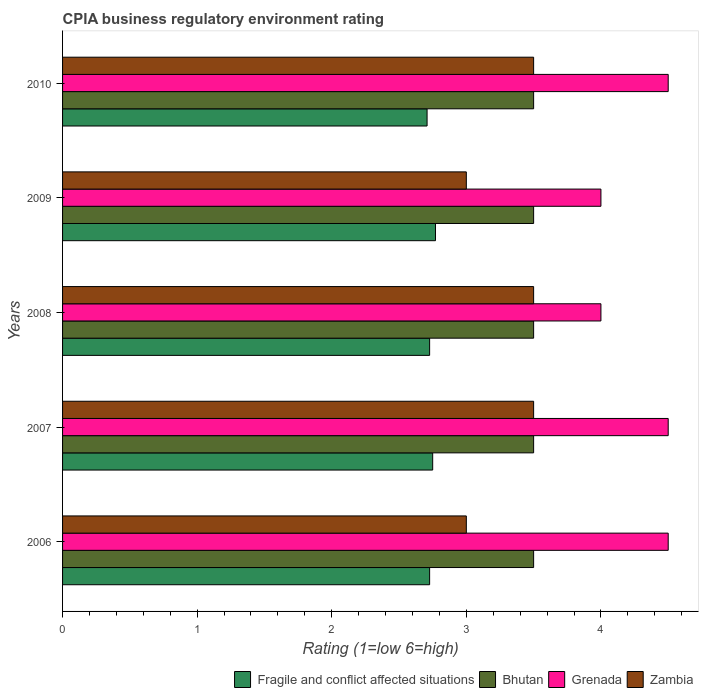How many different coloured bars are there?
Keep it short and to the point. 4. How many groups of bars are there?
Keep it short and to the point. 5. Are the number of bars per tick equal to the number of legend labels?
Keep it short and to the point. Yes. Across all years, what is the maximum CPIA rating in Fragile and conflict affected situations?
Provide a succinct answer. 2.77. Across all years, what is the minimum CPIA rating in Fragile and conflict affected situations?
Make the answer very short. 2.71. In which year was the CPIA rating in Zambia maximum?
Ensure brevity in your answer.  2007. What is the total CPIA rating in Fragile and conflict affected situations in the graph?
Your answer should be very brief. 13.68. What is the difference between the CPIA rating in Grenada in 2007 and that in 2008?
Provide a short and direct response. 0.5. What is the average CPIA rating in Fragile and conflict affected situations per year?
Ensure brevity in your answer.  2.74. In the year 2006, what is the difference between the CPIA rating in Bhutan and CPIA rating in Fragile and conflict affected situations?
Keep it short and to the point. 0.77. In how many years, is the CPIA rating in Grenada greater than 4.4 ?
Give a very brief answer. 3. What is the ratio of the CPIA rating in Fragile and conflict affected situations in 2008 to that in 2009?
Make the answer very short. 0.98. Is the CPIA rating in Bhutan in 2007 less than that in 2008?
Offer a very short reply. No. What is the difference between the highest and the lowest CPIA rating in Fragile and conflict affected situations?
Your answer should be very brief. 0.06. In how many years, is the CPIA rating in Zambia greater than the average CPIA rating in Zambia taken over all years?
Your answer should be very brief. 3. Is it the case that in every year, the sum of the CPIA rating in Zambia and CPIA rating in Fragile and conflict affected situations is greater than the sum of CPIA rating in Grenada and CPIA rating in Bhutan?
Your answer should be very brief. Yes. What does the 3rd bar from the top in 2006 represents?
Give a very brief answer. Bhutan. What does the 1st bar from the bottom in 2007 represents?
Your answer should be very brief. Fragile and conflict affected situations. Does the graph contain any zero values?
Give a very brief answer. No. What is the title of the graph?
Make the answer very short. CPIA business regulatory environment rating. What is the Rating (1=low 6=high) of Fragile and conflict affected situations in 2006?
Provide a short and direct response. 2.73. What is the Rating (1=low 6=high) in Bhutan in 2006?
Make the answer very short. 3.5. What is the Rating (1=low 6=high) of Grenada in 2006?
Your answer should be very brief. 4.5. What is the Rating (1=low 6=high) in Zambia in 2006?
Provide a succinct answer. 3. What is the Rating (1=low 6=high) in Fragile and conflict affected situations in 2007?
Offer a very short reply. 2.75. What is the Rating (1=low 6=high) in Grenada in 2007?
Offer a very short reply. 4.5. What is the Rating (1=low 6=high) in Zambia in 2007?
Your response must be concise. 3.5. What is the Rating (1=low 6=high) in Fragile and conflict affected situations in 2008?
Your response must be concise. 2.73. What is the Rating (1=low 6=high) in Bhutan in 2008?
Provide a short and direct response. 3.5. What is the Rating (1=low 6=high) of Grenada in 2008?
Your answer should be compact. 4. What is the Rating (1=low 6=high) of Zambia in 2008?
Provide a succinct answer. 3.5. What is the Rating (1=low 6=high) of Fragile and conflict affected situations in 2009?
Your answer should be very brief. 2.77. What is the Rating (1=low 6=high) of Grenada in 2009?
Keep it short and to the point. 4. What is the Rating (1=low 6=high) of Fragile and conflict affected situations in 2010?
Provide a short and direct response. 2.71. What is the Rating (1=low 6=high) in Grenada in 2010?
Keep it short and to the point. 4.5. Across all years, what is the maximum Rating (1=low 6=high) of Fragile and conflict affected situations?
Offer a very short reply. 2.77. Across all years, what is the maximum Rating (1=low 6=high) in Grenada?
Provide a short and direct response. 4.5. Across all years, what is the minimum Rating (1=low 6=high) in Fragile and conflict affected situations?
Offer a terse response. 2.71. Across all years, what is the minimum Rating (1=low 6=high) in Grenada?
Your response must be concise. 4. Across all years, what is the minimum Rating (1=low 6=high) of Zambia?
Offer a terse response. 3. What is the total Rating (1=low 6=high) in Fragile and conflict affected situations in the graph?
Provide a succinct answer. 13.68. What is the total Rating (1=low 6=high) of Bhutan in the graph?
Offer a very short reply. 17.5. What is the difference between the Rating (1=low 6=high) of Fragile and conflict affected situations in 2006 and that in 2007?
Offer a terse response. -0.02. What is the difference between the Rating (1=low 6=high) of Bhutan in 2006 and that in 2007?
Your answer should be very brief. 0. What is the difference between the Rating (1=low 6=high) of Grenada in 2006 and that in 2007?
Your answer should be very brief. 0. What is the difference between the Rating (1=low 6=high) of Zambia in 2006 and that in 2007?
Offer a very short reply. -0.5. What is the difference between the Rating (1=low 6=high) of Zambia in 2006 and that in 2008?
Ensure brevity in your answer.  -0.5. What is the difference between the Rating (1=low 6=high) of Fragile and conflict affected situations in 2006 and that in 2009?
Keep it short and to the point. -0.04. What is the difference between the Rating (1=low 6=high) of Bhutan in 2006 and that in 2009?
Provide a short and direct response. 0. What is the difference between the Rating (1=low 6=high) in Zambia in 2006 and that in 2009?
Keep it short and to the point. 0. What is the difference between the Rating (1=low 6=high) in Fragile and conflict affected situations in 2006 and that in 2010?
Offer a terse response. 0.02. What is the difference between the Rating (1=low 6=high) of Bhutan in 2006 and that in 2010?
Provide a succinct answer. 0. What is the difference between the Rating (1=low 6=high) in Grenada in 2006 and that in 2010?
Your answer should be compact. 0. What is the difference between the Rating (1=low 6=high) in Zambia in 2006 and that in 2010?
Provide a short and direct response. -0.5. What is the difference between the Rating (1=low 6=high) in Fragile and conflict affected situations in 2007 and that in 2008?
Offer a terse response. 0.02. What is the difference between the Rating (1=low 6=high) of Bhutan in 2007 and that in 2008?
Ensure brevity in your answer.  0. What is the difference between the Rating (1=low 6=high) in Fragile and conflict affected situations in 2007 and that in 2009?
Make the answer very short. -0.02. What is the difference between the Rating (1=low 6=high) of Bhutan in 2007 and that in 2009?
Keep it short and to the point. 0. What is the difference between the Rating (1=low 6=high) of Zambia in 2007 and that in 2009?
Make the answer very short. 0.5. What is the difference between the Rating (1=low 6=high) of Fragile and conflict affected situations in 2007 and that in 2010?
Keep it short and to the point. 0.04. What is the difference between the Rating (1=low 6=high) of Bhutan in 2007 and that in 2010?
Offer a very short reply. 0. What is the difference between the Rating (1=low 6=high) of Grenada in 2007 and that in 2010?
Provide a short and direct response. 0. What is the difference between the Rating (1=low 6=high) of Fragile and conflict affected situations in 2008 and that in 2009?
Your answer should be very brief. -0.04. What is the difference between the Rating (1=low 6=high) of Grenada in 2008 and that in 2009?
Offer a very short reply. 0. What is the difference between the Rating (1=low 6=high) of Fragile and conflict affected situations in 2008 and that in 2010?
Your answer should be compact. 0.02. What is the difference between the Rating (1=low 6=high) of Bhutan in 2008 and that in 2010?
Ensure brevity in your answer.  0. What is the difference between the Rating (1=low 6=high) in Grenada in 2008 and that in 2010?
Offer a terse response. -0.5. What is the difference between the Rating (1=low 6=high) of Zambia in 2008 and that in 2010?
Your answer should be compact. 0. What is the difference between the Rating (1=low 6=high) in Fragile and conflict affected situations in 2009 and that in 2010?
Your answer should be compact. 0.06. What is the difference between the Rating (1=low 6=high) of Bhutan in 2009 and that in 2010?
Your answer should be very brief. 0. What is the difference between the Rating (1=low 6=high) in Grenada in 2009 and that in 2010?
Provide a short and direct response. -0.5. What is the difference between the Rating (1=low 6=high) in Fragile and conflict affected situations in 2006 and the Rating (1=low 6=high) in Bhutan in 2007?
Give a very brief answer. -0.77. What is the difference between the Rating (1=low 6=high) of Fragile and conflict affected situations in 2006 and the Rating (1=low 6=high) of Grenada in 2007?
Provide a short and direct response. -1.77. What is the difference between the Rating (1=low 6=high) of Fragile and conflict affected situations in 2006 and the Rating (1=low 6=high) of Zambia in 2007?
Give a very brief answer. -0.77. What is the difference between the Rating (1=low 6=high) of Grenada in 2006 and the Rating (1=low 6=high) of Zambia in 2007?
Offer a terse response. 1. What is the difference between the Rating (1=low 6=high) in Fragile and conflict affected situations in 2006 and the Rating (1=low 6=high) in Bhutan in 2008?
Ensure brevity in your answer.  -0.77. What is the difference between the Rating (1=low 6=high) of Fragile and conflict affected situations in 2006 and the Rating (1=low 6=high) of Grenada in 2008?
Your answer should be compact. -1.27. What is the difference between the Rating (1=low 6=high) in Fragile and conflict affected situations in 2006 and the Rating (1=low 6=high) in Zambia in 2008?
Offer a terse response. -0.77. What is the difference between the Rating (1=low 6=high) of Bhutan in 2006 and the Rating (1=low 6=high) of Grenada in 2008?
Keep it short and to the point. -0.5. What is the difference between the Rating (1=low 6=high) in Grenada in 2006 and the Rating (1=low 6=high) in Zambia in 2008?
Provide a succinct answer. 1. What is the difference between the Rating (1=low 6=high) of Fragile and conflict affected situations in 2006 and the Rating (1=low 6=high) of Bhutan in 2009?
Offer a terse response. -0.77. What is the difference between the Rating (1=low 6=high) in Fragile and conflict affected situations in 2006 and the Rating (1=low 6=high) in Grenada in 2009?
Offer a very short reply. -1.27. What is the difference between the Rating (1=low 6=high) of Fragile and conflict affected situations in 2006 and the Rating (1=low 6=high) of Zambia in 2009?
Your response must be concise. -0.27. What is the difference between the Rating (1=low 6=high) of Grenada in 2006 and the Rating (1=low 6=high) of Zambia in 2009?
Offer a terse response. 1.5. What is the difference between the Rating (1=low 6=high) in Fragile and conflict affected situations in 2006 and the Rating (1=low 6=high) in Bhutan in 2010?
Offer a very short reply. -0.77. What is the difference between the Rating (1=low 6=high) of Fragile and conflict affected situations in 2006 and the Rating (1=low 6=high) of Grenada in 2010?
Keep it short and to the point. -1.77. What is the difference between the Rating (1=low 6=high) of Fragile and conflict affected situations in 2006 and the Rating (1=low 6=high) of Zambia in 2010?
Offer a terse response. -0.77. What is the difference between the Rating (1=low 6=high) of Bhutan in 2006 and the Rating (1=low 6=high) of Grenada in 2010?
Offer a terse response. -1. What is the difference between the Rating (1=low 6=high) of Grenada in 2006 and the Rating (1=low 6=high) of Zambia in 2010?
Make the answer very short. 1. What is the difference between the Rating (1=low 6=high) in Fragile and conflict affected situations in 2007 and the Rating (1=low 6=high) in Bhutan in 2008?
Provide a succinct answer. -0.75. What is the difference between the Rating (1=low 6=high) in Fragile and conflict affected situations in 2007 and the Rating (1=low 6=high) in Grenada in 2008?
Give a very brief answer. -1.25. What is the difference between the Rating (1=low 6=high) of Fragile and conflict affected situations in 2007 and the Rating (1=low 6=high) of Zambia in 2008?
Offer a very short reply. -0.75. What is the difference between the Rating (1=low 6=high) of Bhutan in 2007 and the Rating (1=low 6=high) of Grenada in 2008?
Offer a very short reply. -0.5. What is the difference between the Rating (1=low 6=high) of Fragile and conflict affected situations in 2007 and the Rating (1=low 6=high) of Bhutan in 2009?
Your response must be concise. -0.75. What is the difference between the Rating (1=low 6=high) of Fragile and conflict affected situations in 2007 and the Rating (1=low 6=high) of Grenada in 2009?
Your answer should be compact. -1.25. What is the difference between the Rating (1=low 6=high) of Bhutan in 2007 and the Rating (1=low 6=high) of Grenada in 2009?
Give a very brief answer. -0.5. What is the difference between the Rating (1=low 6=high) in Bhutan in 2007 and the Rating (1=low 6=high) in Zambia in 2009?
Offer a very short reply. 0.5. What is the difference between the Rating (1=low 6=high) in Grenada in 2007 and the Rating (1=low 6=high) in Zambia in 2009?
Provide a short and direct response. 1.5. What is the difference between the Rating (1=low 6=high) of Fragile and conflict affected situations in 2007 and the Rating (1=low 6=high) of Bhutan in 2010?
Provide a succinct answer. -0.75. What is the difference between the Rating (1=low 6=high) of Fragile and conflict affected situations in 2007 and the Rating (1=low 6=high) of Grenada in 2010?
Provide a succinct answer. -1.75. What is the difference between the Rating (1=low 6=high) in Fragile and conflict affected situations in 2007 and the Rating (1=low 6=high) in Zambia in 2010?
Your answer should be very brief. -0.75. What is the difference between the Rating (1=low 6=high) of Bhutan in 2007 and the Rating (1=low 6=high) of Zambia in 2010?
Offer a terse response. 0. What is the difference between the Rating (1=low 6=high) in Grenada in 2007 and the Rating (1=low 6=high) in Zambia in 2010?
Provide a succinct answer. 1. What is the difference between the Rating (1=low 6=high) of Fragile and conflict affected situations in 2008 and the Rating (1=low 6=high) of Bhutan in 2009?
Offer a terse response. -0.77. What is the difference between the Rating (1=low 6=high) in Fragile and conflict affected situations in 2008 and the Rating (1=low 6=high) in Grenada in 2009?
Offer a terse response. -1.27. What is the difference between the Rating (1=low 6=high) in Fragile and conflict affected situations in 2008 and the Rating (1=low 6=high) in Zambia in 2009?
Give a very brief answer. -0.27. What is the difference between the Rating (1=low 6=high) of Bhutan in 2008 and the Rating (1=low 6=high) of Zambia in 2009?
Your response must be concise. 0.5. What is the difference between the Rating (1=low 6=high) of Grenada in 2008 and the Rating (1=low 6=high) of Zambia in 2009?
Keep it short and to the point. 1. What is the difference between the Rating (1=low 6=high) in Fragile and conflict affected situations in 2008 and the Rating (1=low 6=high) in Bhutan in 2010?
Your response must be concise. -0.77. What is the difference between the Rating (1=low 6=high) in Fragile and conflict affected situations in 2008 and the Rating (1=low 6=high) in Grenada in 2010?
Provide a succinct answer. -1.77. What is the difference between the Rating (1=low 6=high) in Fragile and conflict affected situations in 2008 and the Rating (1=low 6=high) in Zambia in 2010?
Offer a very short reply. -0.77. What is the difference between the Rating (1=low 6=high) in Bhutan in 2008 and the Rating (1=low 6=high) in Grenada in 2010?
Your response must be concise. -1. What is the difference between the Rating (1=low 6=high) in Grenada in 2008 and the Rating (1=low 6=high) in Zambia in 2010?
Provide a succinct answer. 0.5. What is the difference between the Rating (1=low 6=high) in Fragile and conflict affected situations in 2009 and the Rating (1=low 6=high) in Bhutan in 2010?
Your answer should be very brief. -0.73. What is the difference between the Rating (1=low 6=high) in Fragile and conflict affected situations in 2009 and the Rating (1=low 6=high) in Grenada in 2010?
Your answer should be compact. -1.73. What is the difference between the Rating (1=low 6=high) of Fragile and conflict affected situations in 2009 and the Rating (1=low 6=high) of Zambia in 2010?
Provide a succinct answer. -0.73. What is the difference between the Rating (1=low 6=high) in Bhutan in 2009 and the Rating (1=low 6=high) in Grenada in 2010?
Make the answer very short. -1. What is the difference between the Rating (1=low 6=high) of Bhutan in 2009 and the Rating (1=low 6=high) of Zambia in 2010?
Your answer should be very brief. 0. What is the difference between the Rating (1=low 6=high) in Grenada in 2009 and the Rating (1=low 6=high) in Zambia in 2010?
Make the answer very short. 0.5. What is the average Rating (1=low 6=high) of Fragile and conflict affected situations per year?
Ensure brevity in your answer.  2.74. What is the average Rating (1=low 6=high) of Bhutan per year?
Provide a short and direct response. 3.5. What is the average Rating (1=low 6=high) of Grenada per year?
Offer a terse response. 4.3. In the year 2006, what is the difference between the Rating (1=low 6=high) in Fragile and conflict affected situations and Rating (1=low 6=high) in Bhutan?
Give a very brief answer. -0.77. In the year 2006, what is the difference between the Rating (1=low 6=high) of Fragile and conflict affected situations and Rating (1=low 6=high) of Grenada?
Your answer should be very brief. -1.77. In the year 2006, what is the difference between the Rating (1=low 6=high) in Fragile and conflict affected situations and Rating (1=low 6=high) in Zambia?
Give a very brief answer. -0.27. In the year 2006, what is the difference between the Rating (1=low 6=high) in Grenada and Rating (1=low 6=high) in Zambia?
Your answer should be compact. 1.5. In the year 2007, what is the difference between the Rating (1=low 6=high) of Fragile and conflict affected situations and Rating (1=low 6=high) of Bhutan?
Offer a terse response. -0.75. In the year 2007, what is the difference between the Rating (1=low 6=high) in Fragile and conflict affected situations and Rating (1=low 6=high) in Grenada?
Ensure brevity in your answer.  -1.75. In the year 2007, what is the difference between the Rating (1=low 6=high) of Fragile and conflict affected situations and Rating (1=low 6=high) of Zambia?
Provide a succinct answer. -0.75. In the year 2008, what is the difference between the Rating (1=low 6=high) of Fragile and conflict affected situations and Rating (1=low 6=high) of Bhutan?
Offer a terse response. -0.77. In the year 2008, what is the difference between the Rating (1=low 6=high) of Fragile and conflict affected situations and Rating (1=low 6=high) of Grenada?
Give a very brief answer. -1.27. In the year 2008, what is the difference between the Rating (1=low 6=high) of Fragile and conflict affected situations and Rating (1=low 6=high) of Zambia?
Your answer should be compact. -0.77. In the year 2009, what is the difference between the Rating (1=low 6=high) of Fragile and conflict affected situations and Rating (1=low 6=high) of Bhutan?
Your answer should be compact. -0.73. In the year 2009, what is the difference between the Rating (1=low 6=high) of Fragile and conflict affected situations and Rating (1=low 6=high) of Grenada?
Offer a terse response. -1.23. In the year 2009, what is the difference between the Rating (1=low 6=high) of Fragile and conflict affected situations and Rating (1=low 6=high) of Zambia?
Offer a very short reply. -0.23. In the year 2009, what is the difference between the Rating (1=low 6=high) of Bhutan and Rating (1=low 6=high) of Grenada?
Your answer should be compact. -0.5. In the year 2010, what is the difference between the Rating (1=low 6=high) in Fragile and conflict affected situations and Rating (1=low 6=high) in Bhutan?
Your answer should be very brief. -0.79. In the year 2010, what is the difference between the Rating (1=low 6=high) of Fragile and conflict affected situations and Rating (1=low 6=high) of Grenada?
Keep it short and to the point. -1.79. In the year 2010, what is the difference between the Rating (1=low 6=high) in Fragile and conflict affected situations and Rating (1=low 6=high) in Zambia?
Offer a terse response. -0.79. In the year 2010, what is the difference between the Rating (1=low 6=high) in Bhutan and Rating (1=low 6=high) in Zambia?
Keep it short and to the point. 0. In the year 2010, what is the difference between the Rating (1=low 6=high) in Grenada and Rating (1=low 6=high) in Zambia?
Give a very brief answer. 1. What is the ratio of the Rating (1=low 6=high) in Fragile and conflict affected situations in 2006 to that in 2007?
Offer a terse response. 0.99. What is the ratio of the Rating (1=low 6=high) of Bhutan in 2006 to that in 2007?
Your response must be concise. 1. What is the ratio of the Rating (1=low 6=high) of Zambia in 2006 to that in 2007?
Your answer should be compact. 0.86. What is the ratio of the Rating (1=low 6=high) of Fragile and conflict affected situations in 2006 to that in 2008?
Your answer should be compact. 1. What is the ratio of the Rating (1=low 6=high) of Grenada in 2006 to that in 2008?
Offer a terse response. 1.12. What is the ratio of the Rating (1=low 6=high) in Zambia in 2006 to that in 2008?
Ensure brevity in your answer.  0.86. What is the ratio of the Rating (1=low 6=high) in Fragile and conflict affected situations in 2006 to that in 2009?
Give a very brief answer. 0.98. What is the ratio of the Rating (1=low 6=high) of Bhutan in 2006 to that in 2009?
Your response must be concise. 1. What is the ratio of the Rating (1=low 6=high) of Grenada in 2006 to that in 2009?
Provide a short and direct response. 1.12. What is the ratio of the Rating (1=low 6=high) in Zambia in 2006 to that in 2009?
Your response must be concise. 1. What is the ratio of the Rating (1=low 6=high) of Fragile and conflict affected situations in 2006 to that in 2010?
Give a very brief answer. 1.01. What is the ratio of the Rating (1=low 6=high) of Bhutan in 2006 to that in 2010?
Your response must be concise. 1. What is the ratio of the Rating (1=low 6=high) of Grenada in 2006 to that in 2010?
Your answer should be compact. 1. What is the ratio of the Rating (1=low 6=high) in Zambia in 2006 to that in 2010?
Give a very brief answer. 0.86. What is the ratio of the Rating (1=low 6=high) of Fragile and conflict affected situations in 2007 to that in 2008?
Your response must be concise. 1.01. What is the ratio of the Rating (1=low 6=high) of Bhutan in 2007 to that in 2008?
Give a very brief answer. 1. What is the ratio of the Rating (1=low 6=high) of Grenada in 2007 to that in 2008?
Your answer should be compact. 1.12. What is the ratio of the Rating (1=low 6=high) in Fragile and conflict affected situations in 2007 to that in 2009?
Give a very brief answer. 0.99. What is the ratio of the Rating (1=low 6=high) in Zambia in 2007 to that in 2009?
Keep it short and to the point. 1.17. What is the ratio of the Rating (1=low 6=high) of Fragile and conflict affected situations in 2007 to that in 2010?
Offer a very short reply. 1.02. What is the ratio of the Rating (1=low 6=high) of Bhutan in 2007 to that in 2010?
Provide a short and direct response. 1. What is the ratio of the Rating (1=low 6=high) of Grenada in 2007 to that in 2010?
Provide a succinct answer. 1. What is the ratio of the Rating (1=low 6=high) in Fragile and conflict affected situations in 2008 to that in 2009?
Your answer should be very brief. 0.98. What is the ratio of the Rating (1=low 6=high) of Fragile and conflict affected situations in 2008 to that in 2010?
Your answer should be compact. 1.01. What is the ratio of the Rating (1=low 6=high) of Fragile and conflict affected situations in 2009 to that in 2010?
Provide a short and direct response. 1.02. What is the ratio of the Rating (1=low 6=high) of Grenada in 2009 to that in 2010?
Make the answer very short. 0.89. What is the difference between the highest and the second highest Rating (1=low 6=high) in Fragile and conflict affected situations?
Your answer should be very brief. 0.02. What is the difference between the highest and the second highest Rating (1=low 6=high) of Bhutan?
Your answer should be very brief. 0. What is the difference between the highest and the second highest Rating (1=low 6=high) in Grenada?
Provide a succinct answer. 0. What is the difference between the highest and the second highest Rating (1=low 6=high) of Zambia?
Provide a short and direct response. 0. What is the difference between the highest and the lowest Rating (1=low 6=high) of Fragile and conflict affected situations?
Ensure brevity in your answer.  0.06. What is the difference between the highest and the lowest Rating (1=low 6=high) of Bhutan?
Ensure brevity in your answer.  0. What is the difference between the highest and the lowest Rating (1=low 6=high) of Grenada?
Your response must be concise. 0.5. 